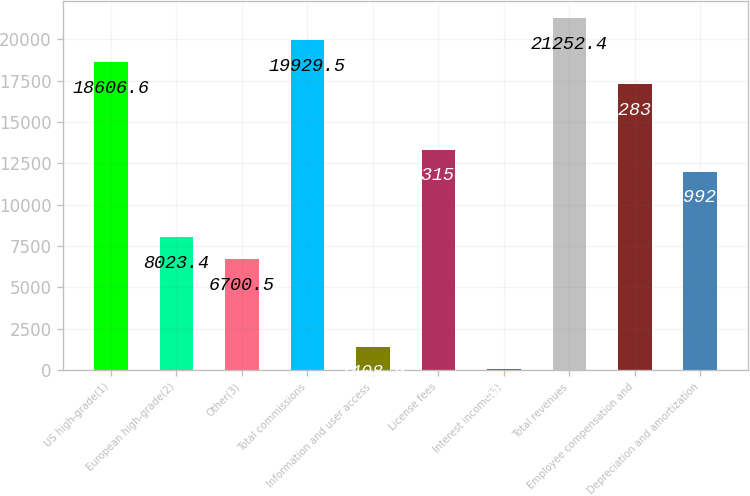Convert chart. <chart><loc_0><loc_0><loc_500><loc_500><bar_chart><fcel>US high-grade(1)<fcel>European high-grade(2)<fcel>Other(3)<fcel>Total commissions<fcel>Information and user access<fcel>License fees<fcel>Interest income(5)<fcel>Total revenues<fcel>Employee compensation and<fcel>Depreciation and amortization<nl><fcel>18606.6<fcel>8023.4<fcel>6700.5<fcel>19929.5<fcel>1408.9<fcel>13315<fcel>86<fcel>21252.4<fcel>17283.7<fcel>11992.1<nl></chart> 